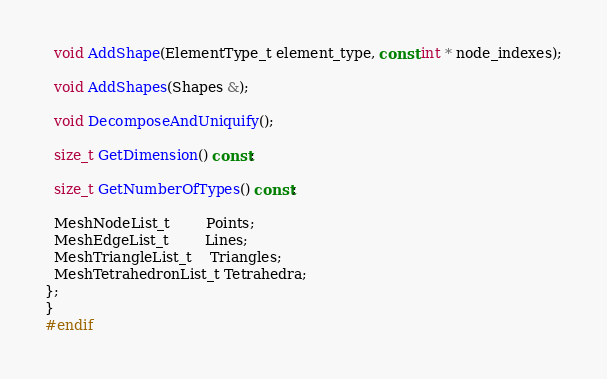Convert code to text. <code><loc_0><loc_0><loc_500><loc_500><_C++_>  void AddShape(ElementType_t element_type, const int * node_indexes);

  void AddShapes(Shapes &);

  void DecomposeAndUniquify();

  size_t GetDimension() const;

  size_t GetNumberOfTypes() const;

  MeshNodeList_t        Points;
  MeshEdgeList_t        Lines;
  MeshTriangleList_t    Triangles;
  MeshTetrahedronList_t Tetrahedra;
};
}
#endif

</code> 